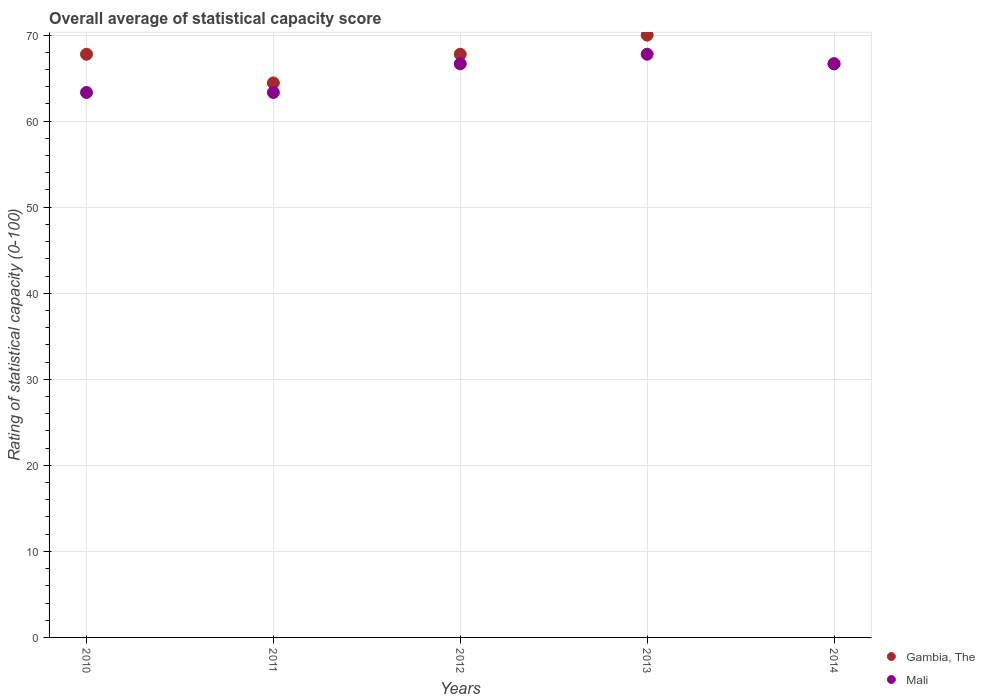Is the number of dotlines equal to the number of legend labels?
Provide a short and direct response. Yes. What is the rating of statistical capacity in Mali in 2013?
Ensure brevity in your answer.  67.78. Across all years, what is the maximum rating of statistical capacity in Gambia, The?
Your response must be concise. 70. Across all years, what is the minimum rating of statistical capacity in Gambia, The?
Offer a very short reply. 64.44. In which year was the rating of statistical capacity in Gambia, The minimum?
Your response must be concise. 2011. What is the total rating of statistical capacity in Mali in the graph?
Ensure brevity in your answer.  327.78. What is the difference between the rating of statistical capacity in Mali in 2010 and that in 2013?
Offer a terse response. -4.44. What is the average rating of statistical capacity in Mali per year?
Offer a very short reply. 65.56. Is the difference between the rating of statistical capacity in Mali in 2011 and 2014 greater than the difference between the rating of statistical capacity in Gambia, The in 2011 and 2014?
Offer a very short reply. No. What is the difference between the highest and the second highest rating of statistical capacity in Gambia, The?
Your answer should be compact. 2.22. What is the difference between the highest and the lowest rating of statistical capacity in Mali?
Give a very brief answer. 4.44. In how many years, is the rating of statistical capacity in Gambia, The greater than the average rating of statistical capacity in Gambia, The taken over all years?
Give a very brief answer. 3. Is the sum of the rating of statistical capacity in Mali in 2011 and 2014 greater than the maximum rating of statistical capacity in Gambia, The across all years?
Your answer should be compact. Yes. Does the rating of statistical capacity in Mali monotonically increase over the years?
Give a very brief answer. No. Is the rating of statistical capacity in Mali strictly less than the rating of statistical capacity in Gambia, The over the years?
Provide a succinct answer. No. How many years are there in the graph?
Give a very brief answer. 5. Are the values on the major ticks of Y-axis written in scientific E-notation?
Provide a short and direct response. No. Where does the legend appear in the graph?
Keep it short and to the point. Bottom right. How many legend labels are there?
Your answer should be compact. 2. How are the legend labels stacked?
Provide a short and direct response. Vertical. What is the title of the graph?
Provide a succinct answer. Overall average of statistical capacity score. What is the label or title of the Y-axis?
Keep it short and to the point. Rating of statistical capacity (0-100). What is the Rating of statistical capacity (0-100) in Gambia, The in 2010?
Your response must be concise. 67.78. What is the Rating of statistical capacity (0-100) in Mali in 2010?
Provide a succinct answer. 63.33. What is the Rating of statistical capacity (0-100) in Gambia, The in 2011?
Provide a succinct answer. 64.44. What is the Rating of statistical capacity (0-100) of Mali in 2011?
Provide a succinct answer. 63.33. What is the Rating of statistical capacity (0-100) of Gambia, The in 2012?
Your answer should be very brief. 67.78. What is the Rating of statistical capacity (0-100) in Mali in 2012?
Provide a succinct answer. 66.67. What is the Rating of statistical capacity (0-100) in Gambia, The in 2013?
Provide a succinct answer. 70. What is the Rating of statistical capacity (0-100) of Mali in 2013?
Make the answer very short. 67.78. What is the Rating of statistical capacity (0-100) in Gambia, The in 2014?
Provide a succinct answer. 66.67. What is the Rating of statistical capacity (0-100) in Mali in 2014?
Your answer should be compact. 66.67. Across all years, what is the maximum Rating of statistical capacity (0-100) of Gambia, The?
Ensure brevity in your answer.  70. Across all years, what is the maximum Rating of statistical capacity (0-100) of Mali?
Keep it short and to the point. 67.78. Across all years, what is the minimum Rating of statistical capacity (0-100) in Gambia, The?
Make the answer very short. 64.44. Across all years, what is the minimum Rating of statistical capacity (0-100) of Mali?
Offer a terse response. 63.33. What is the total Rating of statistical capacity (0-100) of Gambia, The in the graph?
Offer a very short reply. 336.67. What is the total Rating of statistical capacity (0-100) in Mali in the graph?
Provide a short and direct response. 327.78. What is the difference between the Rating of statistical capacity (0-100) in Gambia, The in 2010 and that in 2013?
Provide a short and direct response. -2.22. What is the difference between the Rating of statistical capacity (0-100) in Mali in 2010 and that in 2013?
Your answer should be very brief. -4.44. What is the difference between the Rating of statistical capacity (0-100) of Gambia, The in 2010 and that in 2014?
Give a very brief answer. 1.11. What is the difference between the Rating of statistical capacity (0-100) of Gambia, The in 2011 and that in 2013?
Give a very brief answer. -5.56. What is the difference between the Rating of statistical capacity (0-100) in Mali in 2011 and that in 2013?
Your response must be concise. -4.44. What is the difference between the Rating of statistical capacity (0-100) of Gambia, The in 2011 and that in 2014?
Provide a succinct answer. -2.22. What is the difference between the Rating of statistical capacity (0-100) in Mali in 2011 and that in 2014?
Ensure brevity in your answer.  -3.33. What is the difference between the Rating of statistical capacity (0-100) in Gambia, The in 2012 and that in 2013?
Make the answer very short. -2.22. What is the difference between the Rating of statistical capacity (0-100) of Mali in 2012 and that in 2013?
Your answer should be very brief. -1.11. What is the difference between the Rating of statistical capacity (0-100) of Gambia, The in 2012 and that in 2014?
Give a very brief answer. 1.11. What is the difference between the Rating of statistical capacity (0-100) of Mali in 2012 and that in 2014?
Keep it short and to the point. 0. What is the difference between the Rating of statistical capacity (0-100) of Gambia, The in 2010 and the Rating of statistical capacity (0-100) of Mali in 2011?
Give a very brief answer. 4.44. What is the difference between the Rating of statistical capacity (0-100) in Gambia, The in 2010 and the Rating of statistical capacity (0-100) in Mali in 2012?
Your response must be concise. 1.11. What is the difference between the Rating of statistical capacity (0-100) of Gambia, The in 2011 and the Rating of statistical capacity (0-100) of Mali in 2012?
Keep it short and to the point. -2.22. What is the difference between the Rating of statistical capacity (0-100) in Gambia, The in 2011 and the Rating of statistical capacity (0-100) in Mali in 2013?
Provide a short and direct response. -3.33. What is the difference between the Rating of statistical capacity (0-100) of Gambia, The in 2011 and the Rating of statistical capacity (0-100) of Mali in 2014?
Offer a terse response. -2.22. What is the difference between the Rating of statistical capacity (0-100) in Gambia, The in 2012 and the Rating of statistical capacity (0-100) in Mali in 2013?
Your answer should be very brief. 0. What is the difference between the Rating of statistical capacity (0-100) of Gambia, The in 2012 and the Rating of statistical capacity (0-100) of Mali in 2014?
Provide a succinct answer. 1.11. What is the average Rating of statistical capacity (0-100) of Gambia, The per year?
Give a very brief answer. 67.33. What is the average Rating of statistical capacity (0-100) in Mali per year?
Ensure brevity in your answer.  65.56. In the year 2010, what is the difference between the Rating of statistical capacity (0-100) of Gambia, The and Rating of statistical capacity (0-100) of Mali?
Offer a very short reply. 4.44. In the year 2012, what is the difference between the Rating of statistical capacity (0-100) in Gambia, The and Rating of statistical capacity (0-100) in Mali?
Your answer should be compact. 1.11. In the year 2013, what is the difference between the Rating of statistical capacity (0-100) of Gambia, The and Rating of statistical capacity (0-100) of Mali?
Keep it short and to the point. 2.22. In the year 2014, what is the difference between the Rating of statistical capacity (0-100) in Gambia, The and Rating of statistical capacity (0-100) in Mali?
Provide a succinct answer. 0. What is the ratio of the Rating of statistical capacity (0-100) in Gambia, The in 2010 to that in 2011?
Your answer should be very brief. 1.05. What is the ratio of the Rating of statistical capacity (0-100) of Gambia, The in 2010 to that in 2012?
Give a very brief answer. 1. What is the ratio of the Rating of statistical capacity (0-100) in Gambia, The in 2010 to that in 2013?
Offer a very short reply. 0.97. What is the ratio of the Rating of statistical capacity (0-100) of Mali in 2010 to that in 2013?
Offer a terse response. 0.93. What is the ratio of the Rating of statistical capacity (0-100) in Gambia, The in 2010 to that in 2014?
Your response must be concise. 1.02. What is the ratio of the Rating of statistical capacity (0-100) of Mali in 2010 to that in 2014?
Your response must be concise. 0.95. What is the ratio of the Rating of statistical capacity (0-100) of Gambia, The in 2011 to that in 2012?
Provide a succinct answer. 0.95. What is the ratio of the Rating of statistical capacity (0-100) in Mali in 2011 to that in 2012?
Make the answer very short. 0.95. What is the ratio of the Rating of statistical capacity (0-100) of Gambia, The in 2011 to that in 2013?
Ensure brevity in your answer.  0.92. What is the ratio of the Rating of statistical capacity (0-100) of Mali in 2011 to that in 2013?
Provide a short and direct response. 0.93. What is the ratio of the Rating of statistical capacity (0-100) of Gambia, The in 2011 to that in 2014?
Your answer should be compact. 0.97. What is the ratio of the Rating of statistical capacity (0-100) of Mali in 2011 to that in 2014?
Provide a short and direct response. 0.95. What is the ratio of the Rating of statistical capacity (0-100) in Gambia, The in 2012 to that in 2013?
Give a very brief answer. 0.97. What is the ratio of the Rating of statistical capacity (0-100) in Mali in 2012 to that in 2013?
Keep it short and to the point. 0.98. What is the ratio of the Rating of statistical capacity (0-100) in Gambia, The in 2012 to that in 2014?
Offer a very short reply. 1.02. What is the ratio of the Rating of statistical capacity (0-100) in Mali in 2012 to that in 2014?
Offer a terse response. 1. What is the ratio of the Rating of statistical capacity (0-100) in Gambia, The in 2013 to that in 2014?
Ensure brevity in your answer.  1.05. What is the ratio of the Rating of statistical capacity (0-100) of Mali in 2013 to that in 2014?
Provide a succinct answer. 1.02. What is the difference between the highest and the second highest Rating of statistical capacity (0-100) of Gambia, The?
Provide a succinct answer. 2.22. What is the difference between the highest and the second highest Rating of statistical capacity (0-100) of Mali?
Offer a terse response. 1.11. What is the difference between the highest and the lowest Rating of statistical capacity (0-100) in Gambia, The?
Offer a terse response. 5.56. What is the difference between the highest and the lowest Rating of statistical capacity (0-100) in Mali?
Offer a terse response. 4.44. 